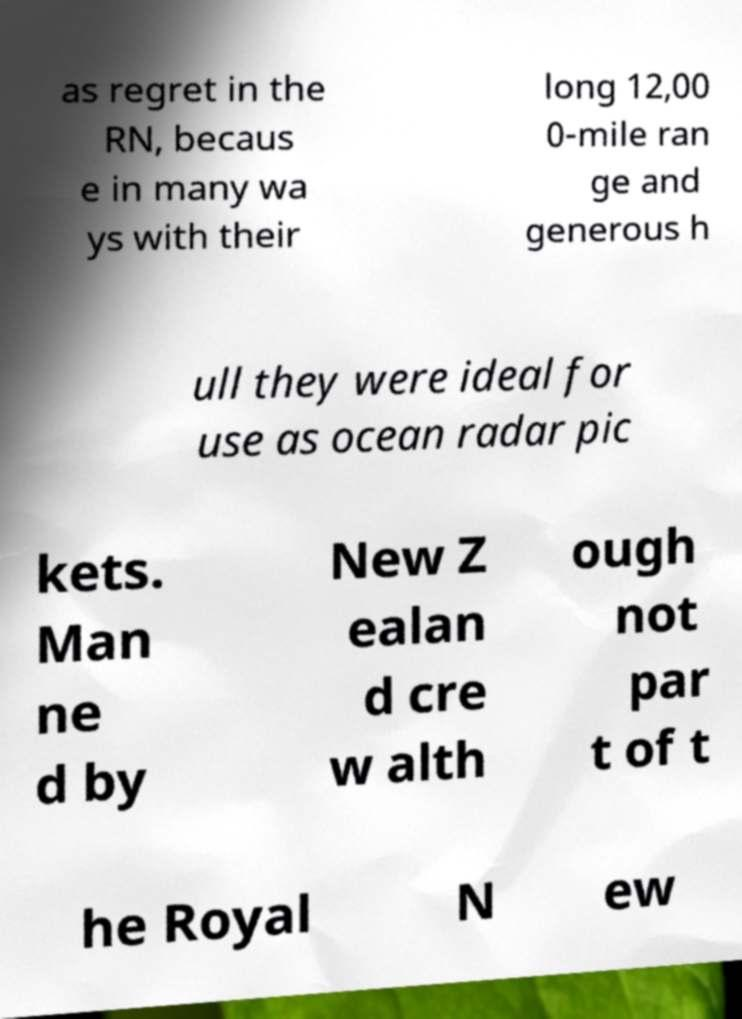Could you extract and type out the text from this image? as regret in the RN, becaus e in many wa ys with their long 12,00 0-mile ran ge and generous h ull they were ideal for use as ocean radar pic kets. Man ne d by New Z ealan d cre w alth ough not par t of t he Royal N ew 